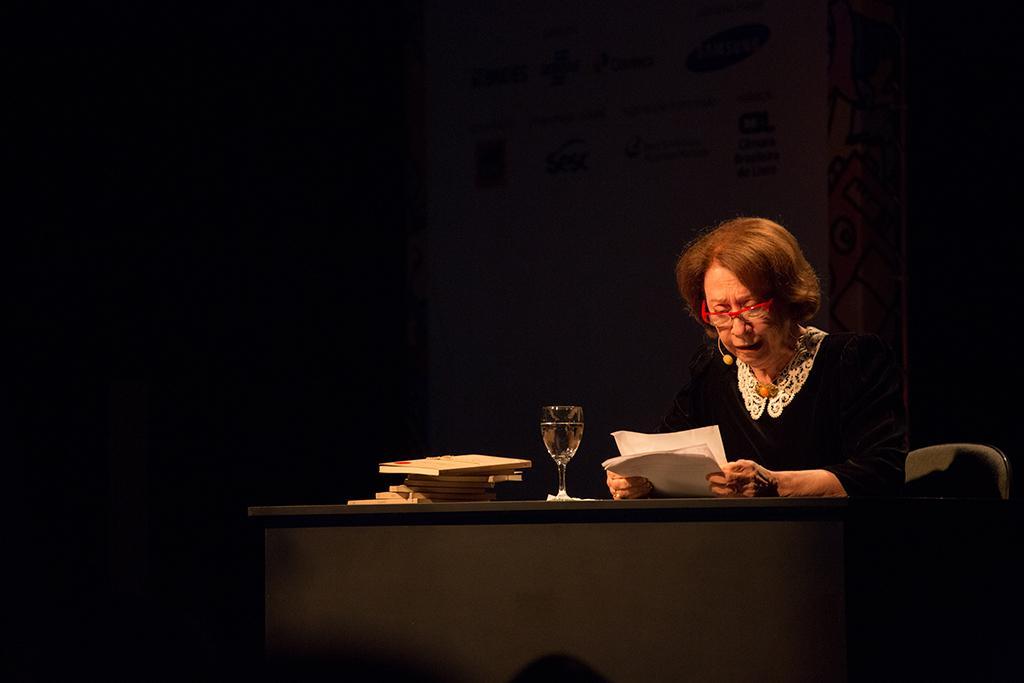Please provide a concise description of this image. In this picture a lady is sitting on the table and reading the document with a glass of juice beside her. 